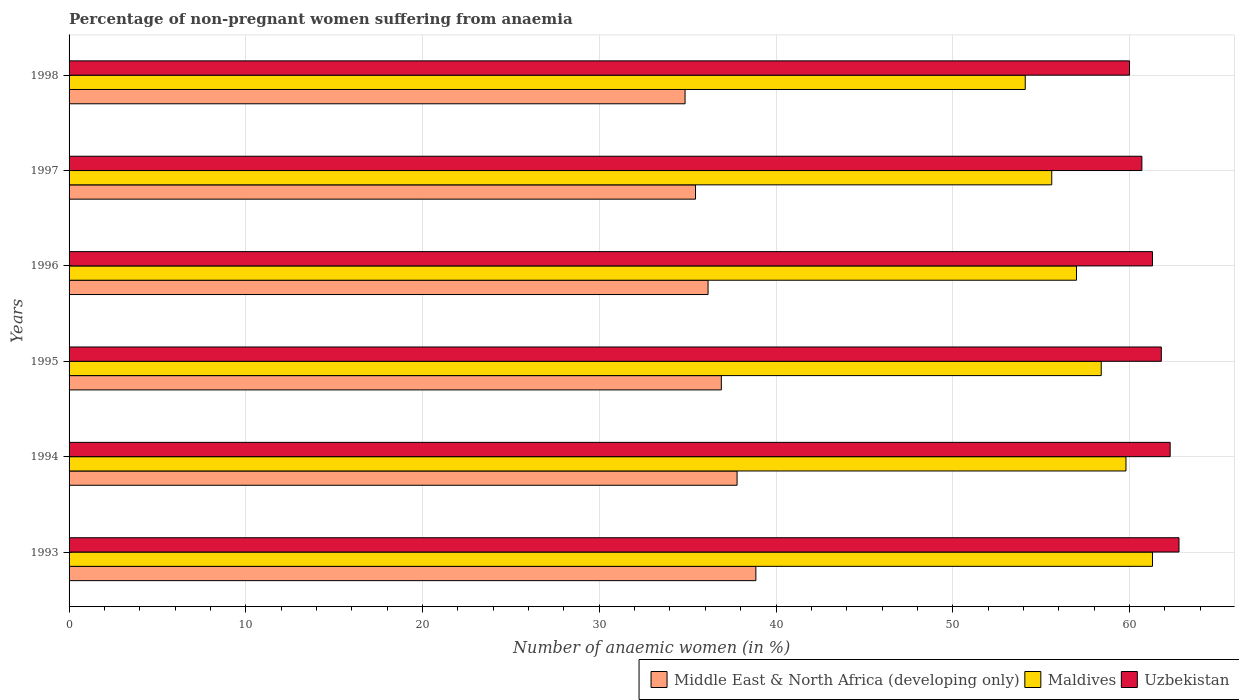How many groups of bars are there?
Your answer should be very brief. 6. Are the number of bars on each tick of the Y-axis equal?
Provide a succinct answer. Yes. How many bars are there on the 2nd tick from the top?
Provide a succinct answer. 3. What is the label of the 6th group of bars from the top?
Offer a terse response. 1993. In how many cases, is the number of bars for a given year not equal to the number of legend labels?
Make the answer very short. 0. What is the percentage of non-pregnant women suffering from anaemia in Uzbekistan in 1995?
Make the answer very short. 61.8. Across all years, what is the maximum percentage of non-pregnant women suffering from anaemia in Middle East & North Africa (developing only)?
Offer a very short reply. 38.86. What is the total percentage of non-pregnant women suffering from anaemia in Maldives in the graph?
Your response must be concise. 346.2. What is the difference between the percentage of non-pregnant women suffering from anaemia in Uzbekistan in 1994 and that in 1997?
Give a very brief answer. 1.6. What is the difference between the percentage of non-pregnant women suffering from anaemia in Maldives in 1997 and the percentage of non-pregnant women suffering from anaemia in Uzbekistan in 1995?
Give a very brief answer. -6.2. What is the average percentage of non-pregnant women suffering from anaemia in Uzbekistan per year?
Your answer should be very brief. 61.48. In the year 1996, what is the difference between the percentage of non-pregnant women suffering from anaemia in Middle East & North Africa (developing only) and percentage of non-pregnant women suffering from anaemia in Maldives?
Provide a succinct answer. -20.85. What is the ratio of the percentage of non-pregnant women suffering from anaemia in Middle East & North Africa (developing only) in 1993 to that in 1997?
Ensure brevity in your answer.  1.1. What is the difference between the highest and the second highest percentage of non-pregnant women suffering from anaemia in Middle East & North Africa (developing only)?
Provide a succinct answer. 1.06. What is the difference between the highest and the lowest percentage of non-pregnant women suffering from anaemia in Maldives?
Your answer should be compact. 7.2. In how many years, is the percentage of non-pregnant women suffering from anaemia in Maldives greater than the average percentage of non-pregnant women suffering from anaemia in Maldives taken over all years?
Ensure brevity in your answer.  3. What does the 1st bar from the top in 1994 represents?
Your answer should be very brief. Uzbekistan. What does the 1st bar from the bottom in 1995 represents?
Your answer should be compact. Middle East & North Africa (developing only). Is it the case that in every year, the sum of the percentage of non-pregnant women suffering from anaemia in Uzbekistan and percentage of non-pregnant women suffering from anaemia in Middle East & North Africa (developing only) is greater than the percentage of non-pregnant women suffering from anaemia in Maldives?
Offer a very short reply. Yes. How many bars are there?
Your response must be concise. 18. How many years are there in the graph?
Your answer should be very brief. 6. What is the difference between two consecutive major ticks on the X-axis?
Ensure brevity in your answer.  10. Where does the legend appear in the graph?
Make the answer very short. Bottom right. What is the title of the graph?
Provide a short and direct response. Percentage of non-pregnant women suffering from anaemia. Does "Cyprus" appear as one of the legend labels in the graph?
Your response must be concise. No. What is the label or title of the X-axis?
Your response must be concise. Number of anaemic women (in %). What is the Number of anaemic women (in %) of Middle East & North Africa (developing only) in 1993?
Provide a succinct answer. 38.86. What is the Number of anaemic women (in %) in Maldives in 1993?
Keep it short and to the point. 61.3. What is the Number of anaemic women (in %) of Uzbekistan in 1993?
Offer a very short reply. 62.8. What is the Number of anaemic women (in %) in Middle East & North Africa (developing only) in 1994?
Offer a terse response. 37.8. What is the Number of anaemic women (in %) in Maldives in 1994?
Keep it short and to the point. 59.8. What is the Number of anaemic women (in %) in Uzbekistan in 1994?
Your answer should be very brief. 62.3. What is the Number of anaemic women (in %) in Middle East & North Africa (developing only) in 1995?
Offer a very short reply. 36.9. What is the Number of anaemic women (in %) of Maldives in 1995?
Your answer should be compact. 58.4. What is the Number of anaemic women (in %) in Uzbekistan in 1995?
Keep it short and to the point. 61.8. What is the Number of anaemic women (in %) in Middle East & North Africa (developing only) in 1996?
Provide a succinct answer. 36.15. What is the Number of anaemic women (in %) in Maldives in 1996?
Give a very brief answer. 57. What is the Number of anaemic women (in %) in Uzbekistan in 1996?
Offer a terse response. 61.3. What is the Number of anaemic women (in %) in Middle East & North Africa (developing only) in 1997?
Offer a very short reply. 35.44. What is the Number of anaemic women (in %) of Maldives in 1997?
Provide a succinct answer. 55.6. What is the Number of anaemic women (in %) in Uzbekistan in 1997?
Provide a short and direct response. 60.7. What is the Number of anaemic women (in %) of Middle East & North Africa (developing only) in 1998?
Your answer should be compact. 34.85. What is the Number of anaemic women (in %) of Maldives in 1998?
Provide a short and direct response. 54.1. What is the Number of anaemic women (in %) of Uzbekistan in 1998?
Offer a very short reply. 60. Across all years, what is the maximum Number of anaemic women (in %) in Middle East & North Africa (developing only)?
Provide a succinct answer. 38.86. Across all years, what is the maximum Number of anaemic women (in %) of Maldives?
Your answer should be compact. 61.3. Across all years, what is the maximum Number of anaemic women (in %) of Uzbekistan?
Your answer should be compact. 62.8. Across all years, what is the minimum Number of anaemic women (in %) in Middle East & North Africa (developing only)?
Your response must be concise. 34.85. Across all years, what is the minimum Number of anaemic women (in %) of Maldives?
Provide a succinct answer. 54.1. What is the total Number of anaemic women (in %) in Middle East & North Africa (developing only) in the graph?
Provide a short and direct response. 220.01. What is the total Number of anaemic women (in %) in Maldives in the graph?
Make the answer very short. 346.2. What is the total Number of anaemic women (in %) in Uzbekistan in the graph?
Provide a succinct answer. 368.9. What is the difference between the Number of anaemic women (in %) in Middle East & North Africa (developing only) in 1993 and that in 1994?
Your answer should be compact. 1.06. What is the difference between the Number of anaemic women (in %) of Uzbekistan in 1993 and that in 1994?
Your response must be concise. 0.5. What is the difference between the Number of anaemic women (in %) in Middle East & North Africa (developing only) in 1993 and that in 1995?
Offer a very short reply. 1.95. What is the difference between the Number of anaemic women (in %) in Maldives in 1993 and that in 1995?
Your answer should be compact. 2.9. What is the difference between the Number of anaemic women (in %) of Uzbekistan in 1993 and that in 1995?
Your answer should be very brief. 1. What is the difference between the Number of anaemic women (in %) in Middle East & North Africa (developing only) in 1993 and that in 1996?
Offer a very short reply. 2.71. What is the difference between the Number of anaemic women (in %) in Maldives in 1993 and that in 1996?
Provide a short and direct response. 4.3. What is the difference between the Number of anaemic women (in %) of Middle East & North Africa (developing only) in 1993 and that in 1997?
Give a very brief answer. 3.42. What is the difference between the Number of anaemic women (in %) of Maldives in 1993 and that in 1997?
Give a very brief answer. 5.7. What is the difference between the Number of anaemic women (in %) of Middle East & North Africa (developing only) in 1993 and that in 1998?
Provide a succinct answer. 4.01. What is the difference between the Number of anaemic women (in %) of Middle East & North Africa (developing only) in 1994 and that in 1995?
Your answer should be very brief. 0.89. What is the difference between the Number of anaemic women (in %) in Middle East & North Africa (developing only) in 1994 and that in 1996?
Offer a very short reply. 1.64. What is the difference between the Number of anaemic women (in %) in Middle East & North Africa (developing only) in 1994 and that in 1997?
Make the answer very short. 2.35. What is the difference between the Number of anaemic women (in %) in Middle East & North Africa (developing only) in 1994 and that in 1998?
Provide a succinct answer. 2.94. What is the difference between the Number of anaemic women (in %) in Maldives in 1994 and that in 1998?
Provide a succinct answer. 5.7. What is the difference between the Number of anaemic women (in %) of Middle East & North Africa (developing only) in 1995 and that in 1996?
Provide a succinct answer. 0.75. What is the difference between the Number of anaemic women (in %) in Maldives in 1995 and that in 1996?
Offer a very short reply. 1.4. What is the difference between the Number of anaemic women (in %) of Middle East & North Africa (developing only) in 1995 and that in 1997?
Make the answer very short. 1.46. What is the difference between the Number of anaemic women (in %) of Maldives in 1995 and that in 1997?
Provide a succinct answer. 2.8. What is the difference between the Number of anaemic women (in %) in Uzbekistan in 1995 and that in 1997?
Make the answer very short. 1.1. What is the difference between the Number of anaemic women (in %) in Middle East & North Africa (developing only) in 1995 and that in 1998?
Offer a terse response. 2.05. What is the difference between the Number of anaemic women (in %) in Uzbekistan in 1995 and that in 1998?
Your answer should be compact. 1.8. What is the difference between the Number of anaemic women (in %) in Middle East & North Africa (developing only) in 1996 and that in 1997?
Your response must be concise. 0.71. What is the difference between the Number of anaemic women (in %) of Maldives in 1996 and that in 1997?
Provide a short and direct response. 1.4. What is the difference between the Number of anaemic women (in %) of Middle East & North Africa (developing only) in 1996 and that in 1998?
Provide a short and direct response. 1.3. What is the difference between the Number of anaemic women (in %) in Middle East & North Africa (developing only) in 1997 and that in 1998?
Make the answer very short. 0.59. What is the difference between the Number of anaemic women (in %) of Maldives in 1997 and that in 1998?
Ensure brevity in your answer.  1.5. What is the difference between the Number of anaemic women (in %) of Uzbekistan in 1997 and that in 1998?
Provide a short and direct response. 0.7. What is the difference between the Number of anaemic women (in %) of Middle East & North Africa (developing only) in 1993 and the Number of anaemic women (in %) of Maldives in 1994?
Keep it short and to the point. -20.94. What is the difference between the Number of anaemic women (in %) in Middle East & North Africa (developing only) in 1993 and the Number of anaemic women (in %) in Uzbekistan in 1994?
Make the answer very short. -23.44. What is the difference between the Number of anaemic women (in %) in Maldives in 1993 and the Number of anaemic women (in %) in Uzbekistan in 1994?
Ensure brevity in your answer.  -1. What is the difference between the Number of anaemic women (in %) in Middle East & North Africa (developing only) in 1993 and the Number of anaemic women (in %) in Maldives in 1995?
Offer a very short reply. -19.54. What is the difference between the Number of anaemic women (in %) in Middle East & North Africa (developing only) in 1993 and the Number of anaemic women (in %) in Uzbekistan in 1995?
Give a very brief answer. -22.94. What is the difference between the Number of anaemic women (in %) in Maldives in 1993 and the Number of anaemic women (in %) in Uzbekistan in 1995?
Keep it short and to the point. -0.5. What is the difference between the Number of anaemic women (in %) in Middle East & North Africa (developing only) in 1993 and the Number of anaemic women (in %) in Maldives in 1996?
Make the answer very short. -18.14. What is the difference between the Number of anaemic women (in %) of Middle East & North Africa (developing only) in 1993 and the Number of anaemic women (in %) of Uzbekistan in 1996?
Provide a short and direct response. -22.44. What is the difference between the Number of anaemic women (in %) of Maldives in 1993 and the Number of anaemic women (in %) of Uzbekistan in 1996?
Make the answer very short. 0. What is the difference between the Number of anaemic women (in %) of Middle East & North Africa (developing only) in 1993 and the Number of anaemic women (in %) of Maldives in 1997?
Give a very brief answer. -16.74. What is the difference between the Number of anaemic women (in %) of Middle East & North Africa (developing only) in 1993 and the Number of anaemic women (in %) of Uzbekistan in 1997?
Provide a succinct answer. -21.84. What is the difference between the Number of anaemic women (in %) in Middle East & North Africa (developing only) in 1993 and the Number of anaemic women (in %) in Maldives in 1998?
Your answer should be very brief. -15.24. What is the difference between the Number of anaemic women (in %) of Middle East & North Africa (developing only) in 1993 and the Number of anaemic women (in %) of Uzbekistan in 1998?
Your answer should be very brief. -21.14. What is the difference between the Number of anaemic women (in %) of Middle East & North Africa (developing only) in 1994 and the Number of anaemic women (in %) of Maldives in 1995?
Offer a terse response. -20.6. What is the difference between the Number of anaemic women (in %) of Middle East & North Africa (developing only) in 1994 and the Number of anaemic women (in %) of Uzbekistan in 1995?
Your answer should be very brief. -24. What is the difference between the Number of anaemic women (in %) of Maldives in 1994 and the Number of anaemic women (in %) of Uzbekistan in 1995?
Provide a succinct answer. -2. What is the difference between the Number of anaemic women (in %) in Middle East & North Africa (developing only) in 1994 and the Number of anaemic women (in %) in Maldives in 1996?
Provide a short and direct response. -19.2. What is the difference between the Number of anaemic women (in %) of Middle East & North Africa (developing only) in 1994 and the Number of anaemic women (in %) of Uzbekistan in 1996?
Give a very brief answer. -23.5. What is the difference between the Number of anaemic women (in %) in Maldives in 1994 and the Number of anaemic women (in %) in Uzbekistan in 1996?
Offer a very short reply. -1.5. What is the difference between the Number of anaemic women (in %) of Middle East & North Africa (developing only) in 1994 and the Number of anaemic women (in %) of Maldives in 1997?
Make the answer very short. -17.8. What is the difference between the Number of anaemic women (in %) in Middle East & North Africa (developing only) in 1994 and the Number of anaemic women (in %) in Uzbekistan in 1997?
Give a very brief answer. -22.9. What is the difference between the Number of anaemic women (in %) of Maldives in 1994 and the Number of anaemic women (in %) of Uzbekistan in 1997?
Ensure brevity in your answer.  -0.9. What is the difference between the Number of anaemic women (in %) of Middle East & North Africa (developing only) in 1994 and the Number of anaemic women (in %) of Maldives in 1998?
Provide a succinct answer. -16.3. What is the difference between the Number of anaemic women (in %) of Middle East & North Africa (developing only) in 1994 and the Number of anaemic women (in %) of Uzbekistan in 1998?
Make the answer very short. -22.2. What is the difference between the Number of anaemic women (in %) in Middle East & North Africa (developing only) in 1995 and the Number of anaemic women (in %) in Maldives in 1996?
Give a very brief answer. -20.1. What is the difference between the Number of anaemic women (in %) in Middle East & North Africa (developing only) in 1995 and the Number of anaemic women (in %) in Uzbekistan in 1996?
Offer a very short reply. -24.4. What is the difference between the Number of anaemic women (in %) in Maldives in 1995 and the Number of anaemic women (in %) in Uzbekistan in 1996?
Your response must be concise. -2.9. What is the difference between the Number of anaemic women (in %) in Middle East & North Africa (developing only) in 1995 and the Number of anaemic women (in %) in Maldives in 1997?
Your answer should be compact. -18.7. What is the difference between the Number of anaemic women (in %) in Middle East & North Africa (developing only) in 1995 and the Number of anaemic women (in %) in Uzbekistan in 1997?
Your answer should be very brief. -23.8. What is the difference between the Number of anaemic women (in %) in Maldives in 1995 and the Number of anaemic women (in %) in Uzbekistan in 1997?
Give a very brief answer. -2.3. What is the difference between the Number of anaemic women (in %) of Middle East & North Africa (developing only) in 1995 and the Number of anaemic women (in %) of Maldives in 1998?
Your answer should be very brief. -17.2. What is the difference between the Number of anaemic women (in %) in Middle East & North Africa (developing only) in 1995 and the Number of anaemic women (in %) in Uzbekistan in 1998?
Make the answer very short. -23.1. What is the difference between the Number of anaemic women (in %) of Middle East & North Africa (developing only) in 1996 and the Number of anaemic women (in %) of Maldives in 1997?
Provide a short and direct response. -19.45. What is the difference between the Number of anaemic women (in %) of Middle East & North Africa (developing only) in 1996 and the Number of anaemic women (in %) of Uzbekistan in 1997?
Offer a very short reply. -24.55. What is the difference between the Number of anaemic women (in %) in Maldives in 1996 and the Number of anaemic women (in %) in Uzbekistan in 1997?
Offer a terse response. -3.7. What is the difference between the Number of anaemic women (in %) in Middle East & North Africa (developing only) in 1996 and the Number of anaemic women (in %) in Maldives in 1998?
Your answer should be compact. -17.95. What is the difference between the Number of anaemic women (in %) of Middle East & North Africa (developing only) in 1996 and the Number of anaemic women (in %) of Uzbekistan in 1998?
Your answer should be compact. -23.85. What is the difference between the Number of anaemic women (in %) in Middle East & North Africa (developing only) in 1997 and the Number of anaemic women (in %) in Maldives in 1998?
Offer a very short reply. -18.66. What is the difference between the Number of anaemic women (in %) of Middle East & North Africa (developing only) in 1997 and the Number of anaemic women (in %) of Uzbekistan in 1998?
Provide a succinct answer. -24.56. What is the difference between the Number of anaemic women (in %) in Maldives in 1997 and the Number of anaemic women (in %) in Uzbekistan in 1998?
Offer a terse response. -4.4. What is the average Number of anaemic women (in %) of Middle East & North Africa (developing only) per year?
Keep it short and to the point. 36.67. What is the average Number of anaemic women (in %) in Maldives per year?
Make the answer very short. 57.7. What is the average Number of anaemic women (in %) of Uzbekistan per year?
Offer a very short reply. 61.48. In the year 1993, what is the difference between the Number of anaemic women (in %) in Middle East & North Africa (developing only) and Number of anaemic women (in %) in Maldives?
Make the answer very short. -22.44. In the year 1993, what is the difference between the Number of anaemic women (in %) in Middle East & North Africa (developing only) and Number of anaemic women (in %) in Uzbekistan?
Make the answer very short. -23.94. In the year 1994, what is the difference between the Number of anaemic women (in %) of Middle East & North Africa (developing only) and Number of anaemic women (in %) of Maldives?
Give a very brief answer. -22. In the year 1994, what is the difference between the Number of anaemic women (in %) in Middle East & North Africa (developing only) and Number of anaemic women (in %) in Uzbekistan?
Your answer should be compact. -24.5. In the year 1994, what is the difference between the Number of anaemic women (in %) of Maldives and Number of anaemic women (in %) of Uzbekistan?
Your answer should be compact. -2.5. In the year 1995, what is the difference between the Number of anaemic women (in %) of Middle East & North Africa (developing only) and Number of anaemic women (in %) of Maldives?
Offer a terse response. -21.5. In the year 1995, what is the difference between the Number of anaemic women (in %) in Middle East & North Africa (developing only) and Number of anaemic women (in %) in Uzbekistan?
Give a very brief answer. -24.9. In the year 1996, what is the difference between the Number of anaemic women (in %) in Middle East & North Africa (developing only) and Number of anaemic women (in %) in Maldives?
Make the answer very short. -20.85. In the year 1996, what is the difference between the Number of anaemic women (in %) of Middle East & North Africa (developing only) and Number of anaemic women (in %) of Uzbekistan?
Provide a succinct answer. -25.15. In the year 1996, what is the difference between the Number of anaemic women (in %) of Maldives and Number of anaemic women (in %) of Uzbekistan?
Make the answer very short. -4.3. In the year 1997, what is the difference between the Number of anaemic women (in %) of Middle East & North Africa (developing only) and Number of anaemic women (in %) of Maldives?
Your answer should be compact. -20.16. In the year 1997, what is the difference between the Number of anaemic women (in %) of Middle East & North Africa (developing only) and Number of anaemic women (in %) of Uzbekistan?
Provide a succinct answer. -25.26. In the year 1998, what is the difference between the Number of anaemic women (in %) of Middle East & North Africa (developing only) and Number of anaemic women (in %) of Maldives?
Provide a succinct answer. -19.25. In the year 1998, what is the difference between the Number of anaemic women (in %) of Middle East & North Africa (developing only) and Number of anaemic women (in %) of Uzbekistan?
Your answer should be very brief. -25.15. What is the ratio of the Number of anaemic women (in %) of Middle East & North Africa (developing only) in 1993 to that in 1994?
Provide a short and direct response. 1.03. What is the ratio of the Number of anaemic women (in %) in Maldives in 1993 to that in 1994?
Offer a very short reply. 1.03. What is the ratio of the Number of anaemic women (in %) of Uzbekistan in 1993 to that in 1994?
Ensure brevity in your answer.  1.01. What is the ratio of the Number of anaemic women (in %) of Middle East & North Africa (developing only) in 1993 to that in 1995?
Offer a very short reply. 1.05. What is the ratio of the Number of anaemic women (in %) in Maldives in 1993 to that in 1995?
Make the answer very short. 1.05. What is the ratio of the Number of anaemic women (in %) of Uzbekistan in 1993 to that in 1995?
Provide a succinct answer. 1.02. What is the ratio of the Number of anaemic women (in %) in Middle East & North Africa (developing only) in 1993 to that in 1996?
Make the answer very short. 1.07. What is the ratio of the Number of anaemic women (in %) of Maldives in 1993 to that in 1996?
Your answer should be compact. 1.08. What is the ratio of the Number of anaemic women (in %) of Uzbekistan in 1993 to that in 1996?
Your answer should be very brief. 1.02. What is the ratio of the Number of anaemic women (in %) of Middle East & North Africa (developing only) in 1993 to that in 1997?
Your response must be concise. 1.1. What is the ratio of the Number of anaemic women (in %) in Maldives in 1993 to that in 1997?
Your response must be concise. 1.1. What is the ratio of the Number of anaemic women (in %) of Uzbekistan in 1993 to that in 1997?
Ensure brevity in your answer.  1.03. What is the ratio of the Number of anaemic women (in %) of Middle East & North Africa (developing only) in 1993 to that in 1998?
Provide a short and direct response. 1.11. What is the ratio of the Number of anaemic women (in %) in Maldives in 1993 to that in 1998?
Provide a short and direct response. 1.13. What is the ratio of the Number of anaemic women (in %) of Uzbekistan in 1993 to that in 1998?
Provide a short and direct response. 1.05. What is the ratio of the Number of anaemic women (in %) of Middle East & North Africa (developing only) in 1994 to that in 1995?
Your answer should be very brief. 1.02. What is the ratio of the Number of anaemic women (in %) in Uzbekistan in 1994 to that in 1995?
Make the answer very short. 1.01. What is the ratio of the Number of anaemic women (in %) of Middle East & North Africa (developing only) in 1994 to that in 1996?
Make the answer very short. 1.05. What is the ratio of the Number of anaemic women (in %) of Maldives in 1994 to that in 1996?
Your answer should be very brief. 1.05. What is the ratio of the Number of anaemic women (in %) in Uzbekistan in 1994 to that in 1996?
Make the answer very short. 1.02. What is the ratio of the Number of anaemic women (in %) of Middle East & North Africa (developing only) in 1994 to that in 1997?
Ensure brevity in your answer.  1.07. What is the ratio of the Number of anaemic women (in %) in Maldives in 1994 to that in 1997?
Give a very brief answer. 1.08. What is the ratio of the Number of anaemic women (in %) in Uzbekistan in 1994 to that in 1997?
Offer a very short reply. 1.03. What is the ratio of the Number of anaemic women (in %) of Middle East & North Africa (developing only) in 1994 to that in 1998?
Your response must be concise. 1.08. What is the ratio of the Number of anaemic women (in %) in Maldives in 1994 to that in 1998?
Your answer should be compact. 1.11. What is the ratio of the Number of anaemic women (in %) in Uzbekistan in 1994 to that in 1998?
Offer a terse response. 1.04. What is the ratio of the Number of anaemic women (in %) in Middle East & North Africa (developing only) in 1995 to that in 1996?
Your answer should be very brief. 1.02. What is the ratio of the Number of anaemic women (in %) of Maldives in 1995 to that in 1996?
Keep it short and to the point. 1.02. What is the ratio of the Number of anaemic women (in %) in Uzbekistan in 1995 to that in 1996?
Provide a succinct answer. 1.01. What is the ratio of the Number of anaemic women (in %) in Middle East & North Africa (developing only) in 1995 to that in 1997?
Offer a terse response. 1.04. What is the ratio of the Number of anaemic women (in %) of Maldives in 1995 to that in 1997?
Provide a succinct answer. 1.05. What is the ratio of the Number of anaemic women (in %) of Uzbekistan in 1995 to that in 1997?
Provide a succinct answer. 1.02. What is the ratio of the Number of anaemic women (in %) of Middle East & North Africa (developing only) in 1995 to that in 1998?
Make the answer very short. 1.06. What is the ratio of the Number of anaemic women (in %) of Maldives in 1995 to that in 1998?
Ensure brevity in your answer.  1.08. What is the ratio of the Number of anaemic women (in %) of Uzbekistan in 1995 to that in 1998?
Give a very brief answer. 1.03. What is the ratio of the Number of anaemic women (in %) of Middle East & North Africa (developing only) in 1996 to that in 1997?
Make the answer very short. 1.02. What is the ratio of the Number of anaemic women (in %) of Maldives in 1996 to that in 1997?
Offer a very short reply. 1.03. What is the ratio of the Number of anaemic women (in %) of Uzbekistan in 1996 to that in 1997?
Make the answer very short. 1.01. What is the ratio of the Number of anaemic women (in %) in Middle East & North Africa (developing only) in 1996 to that in 1998?
Provide a succinct answer. 1.04. What is the ratio of the Number of anaemic women (in %) in Maldives in 1996 to that in 1998?
Offer a terse response. 1.05. What is the ratio of the Number of anaemic women (in %) of Uzbekistan in 1996 to that in 1998?
Make the answer very short. 1.02. What is the ratio of the Number of anaemic women (in %) in Maldives in 1997 to that in 1998?
Keep it short and to the point. 1.03. What is the ratio of the Number of anaemic women (in %) in Uzbekistan in 1997 to that in 1998?
Your response must be concise. 1.01. What is the difference between the highest and the second highest Number of anaemic women (in %) of Middle East & North Africa (developing only)?
Your answer should be very brief. 1.06. What is the difference between the highest and the second highest Number of anaemic women (in %) of Uzbekistan?
Your answer should be compact. 0.5. What is the difference between the highest and the lowest Number of anaemic women (in %) in Middle East & North Africa (developing only)?
Keep it short and to the point. 4.01. What is the difference between the highest and the lowest Number of anaemic women (in %) of Maldives?
Ensure brevity in your answer.  7.2. What is the difference between the highest and the lowest Number of anaemic women (in %) of Uzbekistan?
Offer a very short reply. 2.8. 